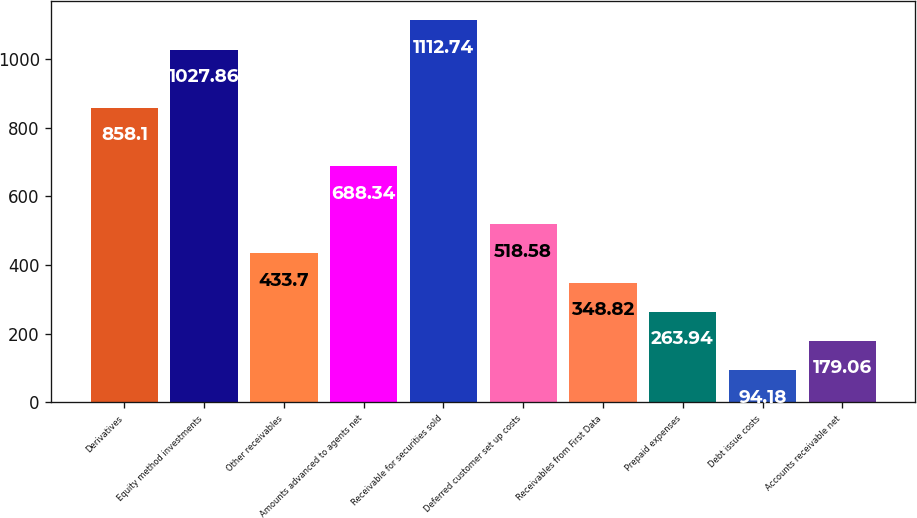Convert chart to OTSL. <chart><loc_0><loc_0><loc_500><loc_500><bar_chart><fcel>Derivatives<fcel>Equity method investments<fcel>Other receivables<fcel>Amounts advanced to agents net<fcel>Receivable for securities sold<fcel>Deferred customer set up costs<fcel>Receivables from First Data<fcel>Prepaid expenses<fcel>Debt issue costs<fcel>Accounts receivable net<nl><fcel>858.1<fcel>1027.86<fcel>433.7<fcel>688.34<fcel>1112.74<fcel>518.58<fcel>348.82<fcel>263.94<fcel>94.18<fcel>179.06<nl></chart> 